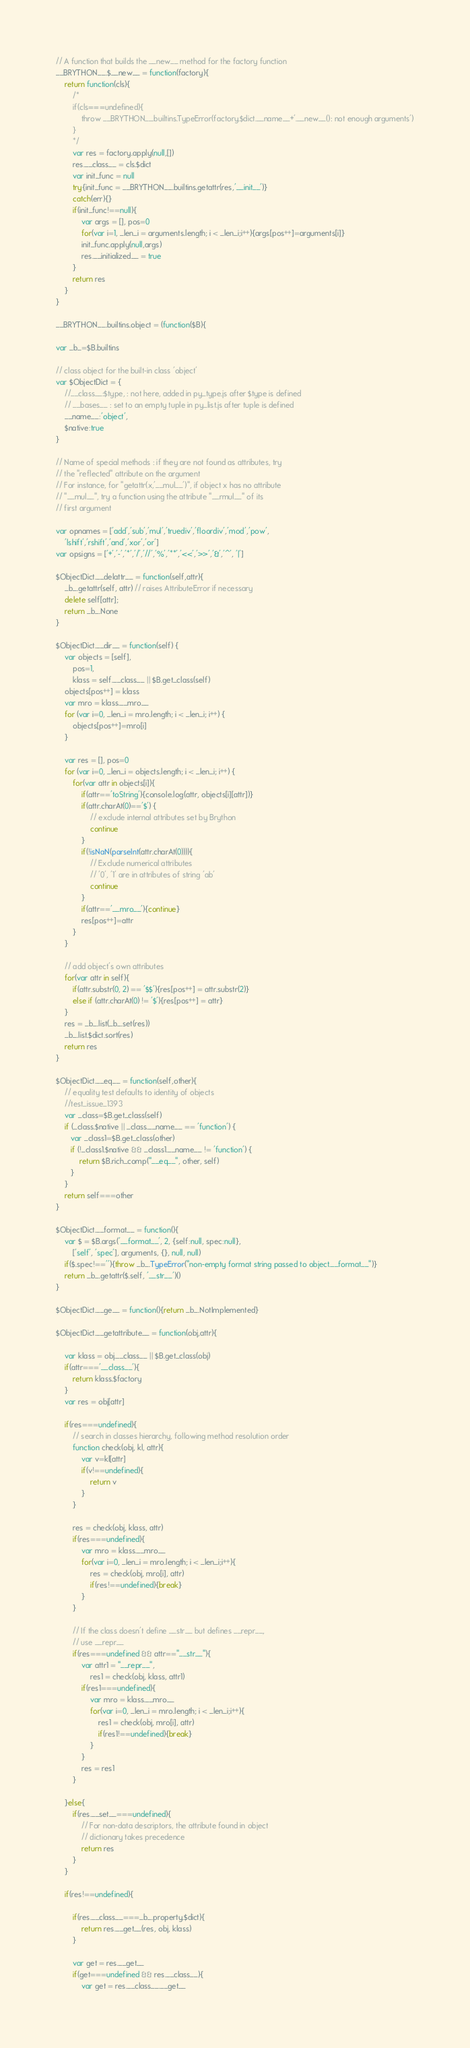<code> <loc_0><loc_0><loc_500><loc_500><_JavaScript_>// A function that builds the __new__ method for the factory function
__BRYTHON__.$__new__ = function(factory){
    return function(cls){
        /*
        if(cls===undefined){
            throw __BRYTHON__.builtins.TypeError(factory.$dict.__name__+'.__new__(): not enough arguments')
        }
        */
        var res = factory.apply(null,[])
        res.__class__ = cls.$dict
        var init_func = null
        try{init_func = __BRYTHON__.builtins.getattr(res,'__init__')}
        catch(err){}
        if(init_func!==null){
            var args = [], pos=0
            for(var i=1, _len_i = arguments.length; i < _len_i;i++){args[pos++]=arguments[i]}
            init_func.apply(null,args)
            res.__initialized__ = true
        }
        return res
    }
}

__BRYTHON__.builtins.object = (function($B){

var _b_=$B.builtins

// class object for the built-in class 'object'
var $ObjectDict = {
    //__class__:$type, : not here, added in py_type.js after $type is defined
    // __bases__ : set to an empty tuple in py_list.js after tuple is defined
    __name__:'object',
    $native:true
}

// Name of special methods : if they are not found as attributes, try
// the "reflected" attribute on the argument
// For instance, for "getattr(x,'__mul__')", if object x has no attribute
// "__mul__", try a function using the attribute "__rmul__" of its
// first argument

var opnames = ['add','sub','mul','truediv','floordiv','mod','pow',
    'lshift','rshift','and','xor','or']
var opsigns = ['+','-','*','/','//','%','**','<<','>>','&','^', '|']

$ObjectDict.__delattr__ = function(self,attr){
    _b_.getattr(self, attr) // raises AttributeError if necessary
    delete self[attr];
    return _b_.None
}

$ObjectDict.__dir__ = function(self) {
    var objects = [self],
        pos=1,
        klass = self.__class__ || $B.get_class(self)
    objects[pos++] = klass
    var mro = klass.__mro__
    for (var i=0, _len_i = mro.length; i < _len_i; i++) {
        objects[pos++]=mro[i]
    }

    var res = [], pos=0
    for (var i=0, _len_i = objects.length; i < _len_i; i++) {
        for(var attr in objects[i]){
            if(attr=='toString'){console.log(attr, objects[i][attr])}
            if(attr.charAt(0)=='$') {
                // exclude internal attributes set by Brython
                continue
            }
            if(!isNaN(parseInt(attr.charAt(0)))){
                // Exclude numerical attributes
                // '0', '1' are in attributes of string 'ab'
                continue
            }
            if(attr=='__mro__'){continue}
            res[pos++]=attr
        }
    }

    // add object's own attributes
    for(var attr in self){
        if(attr.substr(0, 2) == '$$'){res[pos++] = attr.substr(2)}
        else if (attr.charAt(0) != '$'){res[pos++] = attr}
    }
    res = _b_.list(_b_.set(res))
    _b_.list.$dict.sort(res)
    return res
}

$ObjectDict.__eq__ = function(self,other){
    // equality test defaults to identity of objects
    //test_issue_1393
    var _class=$B.get_class(self)
    if (_class.$native || _class.__name__ == 'function') {
       var _class1=$B.get_class(other)
       if (!_class1.$native && _class1.__name__ != 'function') {
           return $B.rich_comp("__eq__", other, self)
       }
    }
    return self===other
}

$ObjectDict.__format__ = function(){
    var $ = $B.args('__format__', 2, {self:null, spec:null},
        ['self', 'spec'], arguments, {}, null, null)
    if($.spec!==''){throw _b_.TypeError("non-empty format string passed to object.__format__")}
    return _b_.getattr($.self, '__str__')()
}

$ObjectDict.__ge__ = function(){return _b_.NotImplemented}

$ObjectDict.__getattribute__ = function(obj,attr){

    var klass = obj.__class__ || $B.get_class(obj)
    if(attr==='__class__'){
        return klass.$factory
    }
    var res = obj[attr]

    if(res===undefined){
        // search in classes hierarchy, following method resolution order
        function check(obj, kl, attr){
            var v=kl[attr]
            if(v!==undefined){
                return v
            }
        }

        res = check(obj, klass, attr)
        if(res===undefined){
            var mro = klass.__mro__
            for(var i=0, _len_i = mro.length; i < _len_i;i++){
                res = check(obj, mro[i], attr)
                if(res!==undefined){break}
            }
        }

        // If the class doesn't define __str__ but defines __repr__,
        // use __repr__
        if(res===undefined && attr=="__str__"){
            var attr1 = "__repr__",
                res1 = check(obj, klass, attr1)
            if(res1===undefined){
                var mro = klass.__mro__
                for(var i=0, _len_i = mro.length; i < _len_i;i++){
                    res1 = check(obj, mro[i], attr)
                    if(res1!==undefined){break}
                }
            }
            res = res1
        }

    }else{
        if(res.__set__===undefined){
            // For non-data descriptors, the attribute found in object
            // dictionary takes precedence
            return res
        }
    }

    if(res!==undefined){

        if(res.__class__===_b_.property.$dict){
            return res.__get__(res, obj, klass)
        }

        var get = res.__get__
        if(get===undefined && res.__class__){
            var get = res.__class__.__get__</code> 